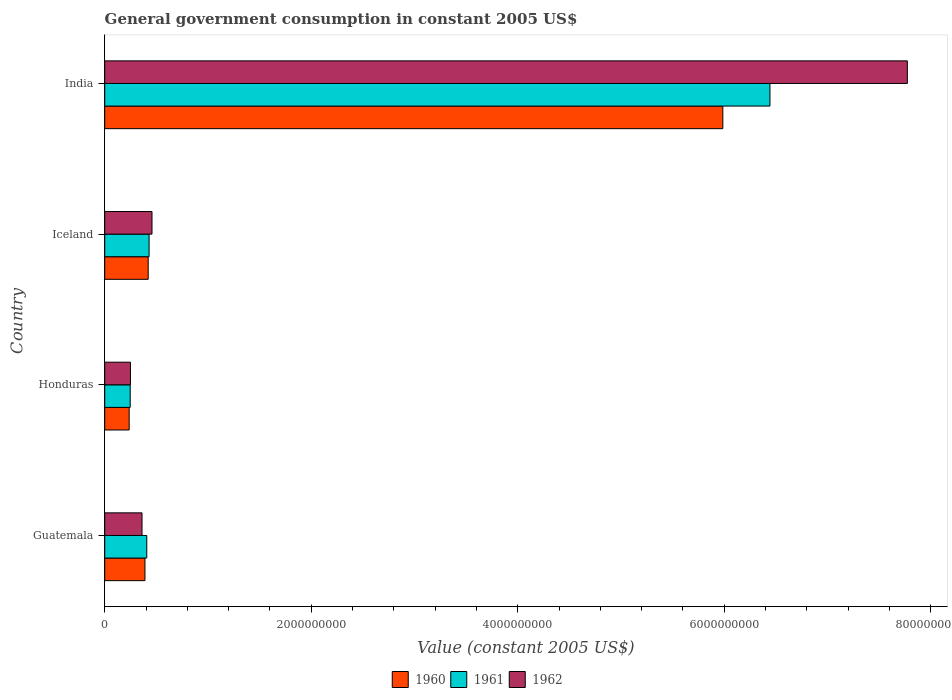What is the government conusmption in 1962 in Guatemala?
Keep it short and to the point. 3.61e+08. Across all countries, what is the maximum government conusmption in 1962?
Your answer should be very brief. 7.77e+09. Across all countries, what is the minimum government conusmption in 1962?
Give a very brief answer. 2.49e+08. In which country was the government conusmption in 1960 maximum?
Offer a terse response. India. In which country was the government conusmption in 1961 minimum?
Offer a terse response. Honduras. What is the total government conusmption in 1961 in the graph?
Your answer should be compact. 7.53e+09. What is the difference between the government conusmption in 1960 in Honduras and that in Iceland?
Your response must be concise. -1.84e+08. What is the difference between the government conusmption in 1960 in India and the government conusmption in 1962 in Honduras?
Your answer should be compact. 5.74e+09. What is the average government conusmption in 1960 per country?
Offer a terse response. 1.76e+09. What is the difference between the government conusmption in 1961 and government conusmption in 1962 in Iceland?
Keep it short and to the point. -2.80e+07. What is the ratio of the government conusmption in 1960 in Guatemala to that in Iceland?
Your response must be concise. 0.93. Is the government conusmption in 1962 in Honduras less than that in Iceland?
Provide a short and direct response. Yes. What is the difference between the highest and the second highest government conusmption in 1962?
Your answer should be compact. 7.32e+09. What is the difference between the highest and the lowest government conusmption in 1961?
Provide a short and direct response. 6.20e+09. What does the 1st bar from the top in Guatemala represents?
Provide a short and direct response. 1962. How many bars are there?
Your answer should be very brief. 12. What is the difference between two consecutive major ticks on the X-axis?
Offer a terse response. 2.00e+09. Where does the legend appear in the graph?
Provide a short and direct response. Bottom center. How many legend labels are there?
Your answer should be very brief. 3. How are the legend labels stacked?
Provide a short and direct response. Horizontal. What is the title of the graph?
Your answer should be compact. General government consumption in constant 2005 US$. Does "1998" appear as one of the legend labels in the graph?
Your answer should be very brief. No. What is the label or title of the X-axis?
Your response must be concise. Value (constant 2005 US$). What is the Value (constant 2005 US$) of 1960 in Guatemala?
Your answer should be very brief. 3.90e+08. What is the Value (constant 2005 US$) of 1961 in Guatemala?
Your response must be concise. 4.07e+08. What is the Value (constant 2005 US$) of 1962 in Guatemala?
Keep it short and to the point. 3.61e+08. What is the Value (constant 2005 US$) of 1960 in Honduras?
Offer a very short reply. 2.37e+08. What is the Value (constant 2005 US$) in 1961 in Honduras?
Keep it short and to the point. 2.47e+08. What is the Value (constant 2005 US$) of 1962 in Honduras?
Offer a terse response. 2.49e+08. What is the Value (constant 2005 US$) in 1960 in Iceland?
Your answer should be compact. 4.21e+08. What is the Value (constant 2005 US$) in 1961 in Iceland?
Offer a very short reply. 4.30e+08. What is the Value (constant 2005 US$) of 1962 in Iceland?
Your answer should be very brief. 4.58e+08. What is the Value (constant 2005 US$) in 1960 in India?
Offer a very short reply. 5.99e+09. What is the Value (constant 2005 US$) in 1961 in India?
Ensure brevity in your answer.  6.44e+09. What is the Value (constant 2005 US$) in 1962 in India?
Provide a succinct answer. 7.77e+09. Across all countries, what is the maximum Value (constant 2005 US$) of 1960?
Your response must be concise. 5.99e+09. Across all countries, what is the maximum Value (constant 2005 US$) of 1961?
Provide a succinct answer. 6.44e+09. Across all countries, what is the maximum Value (constant 2005 US$) in 1962?
Your answer should be compact. 7.77e+09. Across all countries, what is the minimum Value (constant 2005 US$) in 1960?
Make the answer very short. 2.37e+08. Across all countries, what is the minimum Value (constant 2005 US$) of 1961?
Your answer should be very brief. 2.47e+08. Across all countries, what is the minimum Value (constant 2005 US$) of 1962?
Your answer should be compact. 2.49e+08. What is the total Value (constant 2005 US$) in 1960 in the graph?
Your response must be concise. 7.03e+09. What is the total Value (constant 2005 US$) in 1961 in the graph?
Make the answer very short. 7.53e+09. What is the total Value (constant 2005 US$) of 1962 in the graph?
Offer a very short reply. 8.84e+09. What is the difference between the Value (constant 2005 US$) in 1960 in Guatemala and that in Honduras?
Ensure brevity in your answer.  1.53e+08. What is the difference between the Value (constant 2005 US$) in 1961 in Guatemala and that in Honduras?
Offer a very short reply. 1.60e+08. What is the difference between the Value (constant 2005 US$) of 1962 in Guatemala and that in Honduras?
Keep it short and to the point. 1.12e+08. What is the difference between the Value (constant 2005 US$) of 1960 in Guatemala and that in Iceland?
Provide a short and direct response. -3.13e+07. What is the difference between the Value (constant 2005 US$) of 1961 in Guatemala and that in Iceland?
Provide a short and direct response. -2.26e+07. What is the difference between the Value (constant 2005 US$) of 1962 in Guatemala and that in Iceland?
Make the answer very short. -9.66e+07. What is the difference between the Value (constant 2005 US$) in 1960 in Guatemala and that in India?
Your answer should be compact. -5.60e+09. What is the difference between the Value (constant 2005 US$) in 1961 in Guatemala and that in India?
Offer a terse response. -6.04e+09. What is the difference between the Value (constant 2005 US$) of 1962 in Guatemala and that in India?
Offer a very short reply. -7.41e+09. What is the difference between the Value (constant 2005 US$) of 1960 in Honduras and that in Iceland?
Give a very brief answer. -1.84e+08. What is the difference between the Value (constant 2005 US$) in 1961 in Honduras and that in Iceland?
Ensure brevity in your answer.  -1.83e+08. What is the difference between the Value (constant 2005 US$) of 1962 in Honduras and that in Iceland?
Your answer should be very brief. -2.09e+08. What is the difference between the Value (constant 2005 US$) in 1960 in Honduras and that in India?
Your answer should be compact. -5.75e+09. What is the difference between the Value (constant 2005 US$) in 1961 in Honduras and that in India?
Your response must be concise. -6.20e+09. What is the difference between the Value (constant 2005 US$) of 1962 in Honduras and that in India?
Offer a very short reply. -7.52e+09. What is the difference between the Value (constant 2005 US$) in 1960 in Iceland and that in India?
Offer a very short reply. -5.57e+09. What is the difference between the Value (constant 2005 US$) in 1961 in Iceland and that in India?
Offer a very short reply. -6.01e+09. What is the difference between the Value (constant 2005 US$) of 1962 in Iceland and that in India?
Keep it short and to the point. -7.32e+09. What is the difference between the Value (constant 2005 US$) in 1960 in Guatemala and the Value (constant 2005 US$) in 1961 in Honduras?
Provide a short and direct response. 1.43e+08. What is the difference between the Value (constant 2005 US$) of 1960 in Guatemala and the Value (constant 2005 US$) of 1962 in Honduras?
Your response must be concise. 1.40e+08. What is the difference between the Value (constant 2005 US$) of 1961 in Guatemala and the Value (constant 2005 US$) of 1962 in Honduras?
Provide a succinct answer. 1.58e+08. What is the difference between the Value (constant 2005 US$) of 1960 in Guatemala and the Value (constant 2005 US$) of 1961 in Iceland?
Keep it short and to the point. -4.02e+07. What is the difference between the Value (constant 2005 US$) of 1960 in Guatemala and the Value (constant 2005 US$) of 1962 in Iceland?
Offer a very short reply. -6.82e+07. What is the difference between the Value (constant 2005 US$) of 1961 in Guatemala and the Value (constant 2005 US$) of 1962 in Iceland?
Provide a succinct answer. -5.06e+07. What is the difference between the Value (constant 2005 US$) in 1960 in Guatemala and the Value (constant 2005 US$) in 1961 in India?
Provide a short and direct response. -6.05e+09. What is the difference between the Value (constant 2005 US$) of 1960 in Guatemala and the Value (constant 2005 US$) of 1962 in India?
Your response must be concise. -7.38e+09. What is the difference between the Value (constant 2005 US$) in 1961 in Guatemala and the Value (constant 2005 US$) in 1962 in India?
Ensure brevity in your answer.  -7.37e+09. What is the difference between the Value (constant 2005 US$) of 1960 in Honduras and the Value (constant 2005 US$) of 1961 in Iceland?
Provide a succinct answer. -1.93e+08. What is the difference between the Value (constant 2005 US$) in 1960 in Honduras and the Value (constant 2005 US$) in 1962 in Iceland?
Offer a terse response. -2.21e+08. What is the difference between the Value (constant 2005 US$) in 1961 in Honduras and the Value (constant 2005 US$) in 1962 in Iceland?
Keep it short and to the point. -2.11e+08. What is the difference between the Value (constant 2005 US$) in 1960 in Honduras and the Value (constant 2005 US$) in 1961 in India?
Make the answer very short. -6.21e+09. What is the difference between the Value (constant 2005 US$) in 1960 in Honduras and the Value (constant 2005 US$) in 1962 in India?
Your response must be concise. -7.54e+09. What is the difference between the Value (constant 2005 US$) in 1961 in Honduras and the Value (constant 2005 US$) in 1962 in India?
Keep it short and to the point. -7.53e+09. What is the difference between the Value (constant 2005 US$) of 1960 in Iceland and the Value (constant 2005 US$) of 1961 in India?
Keep it short and to the point. -6.02e+09. What is the difference between the Value (constant 2005 US$) of 1960 in Iceland and the Value (constant 2005 US$) of 1962 in India?
Offer a terse response. -7.35e+09. What is the difference between the Value (constant 2005 US$) in 1961 in Iceland and the Value (constant 2005 US$) in 1962 in India?
Provide a succinct answer. -7.34e+09. What is the average Value (constant 2005 US$) in 1960 per country?
Your answer should be compact. 1.76e+09. What is the average Value (constant 2005 US$) in 1961 per country?
Your answer should be very brief. 1.88e+09. What is the average Value (constant 2005 US$) of 1962 per country?
Your answer should be compact. 2.21e+09. What is the difference between the Value (constant 2005 US$) in 1960 and Value (constant 2005 US$) in 1961 in Guatemala?
Make the answer very short. -1.76e+07. What is the difference between the Value (constant 2005 US$) in 1960 and Value (constant 2005 US$) in 1962 in Guatemala?
Your answer should be compact. 2.84e+07. What is the difference between the Value (constant 2005 US$) in 1961 and Value (constant 2005 US$) in 1962 in Guatemala?
Provide a short and direct response. 4.60e+07. What is the difference between the Value (constant 2005 US$) in 1960 and Value (constant 2005 US$) in 1961 in Honduras?
Your answer should be compact. -9.99e+06. What is the difference between the Value (constant 2005 US$) of 1960 and Value (constant 2005 US$) of 1962 in Honduras?
Offer a very short reply. -1.24e+07. What is the difference between the Value (constant 2005 US$) of 1961 and Value (constant 2005 US$) of 1962 in Honduras?
Your answer should be compact. -2.42e+06. What is the difference between the Value (constant 2005 US$) in 1960 and Value (constant 2005 US$) in 1961 in Iceland?
Offer a very short reply. -8.87e+06. What is the difference between the Value (constant 2005 US$) in 1960 and Value (constant 2005 US$) in 1962 in Iceland?
Offer a very short reply. -3.69e+07. What is the difference between the Value (constant 2005 US$) in 1961 and Value (constant 2005 US$) in 1962 in Iceland?
Your response must be concise. -2.80e+07. What is the difference between the Value (constant 2005 US$) of 1960 and Value (constant 2005 US$) of 1961 in India?
Provide a short and direct response. -4.56e+08. What is the difference between the Value (constant 2005 US$) of 1960 and Value (constant 2005 US$) of 1962 in India?
Your answer should be very brief. -1.79e+09. What is the difference between the Value (constant 2005 US$) in 1961 and Value (constant 2005 US$) in 1962 in India?
Ensure brevity in your answer.  -1.33e+09. What is the ratio of the Value (constant 2005 US$) of 1960 in Guatemala to that in Honduras?
Provide a succinct answer. 1.65. What is the ratio of the Value (constant 2005 US$) of 1961 in Guatemala to that in Honduras?
Provide a succinct answer. 1.65. What is the ratio of the Value (constant 2005 US$) in 1962 in Guatemala to that in Honduras?
Keep it short and to the point. 1.45. What is the ratio of the Value (constant 2005 US$) in 1960 in Guatemala to that in Iceland?
Ensure brevity in your answer.  0.93. What is the ratio of the Value (constant 2005 US$) of 1961 in Guatemala to that in Iceland?
Ensure brevity in your answer.  0.95. What is the ratio of the Value (constant 2005 US$) in 1962 in Guatemala to that in Iceland?
Ensure brevity in your answer.  0.79. What is the ratio of the Value (constant 2005 US$) of 1960 in Guatemala to that in India?
Ensure brevity in your answer.  0.07. What is the ratio of the Value (constant 2005 US$) in 1961 in Guatemala to that in India?
Offer a terse response. 0.06. What is the ratio of the Value (constant 2005 US$) of 1962 in Guatemala to that in India?
Give a very brief answer. 0.05. What is the ratio of the Value (constant 2005 US$) in 1960 in Honduras to that in Iceland?
Keep it short and to the point. 0.56. What is the ratio of the Value (constant 2005 US$) of 1961 in Honduras to that in Iceland?
Your answer should be very brief. 0.57. What is the ratio of the Value (constant 2005 US$) of 1962 in Honduras to that in Iceland?
Give a very brief answer. 0.54. What is the ratio of the Value (constant 2005 US$) in 1960 in Honduras to that in India?
Your answer should be compact. 0.04. What is the ratio of the Value (constant 2005 US$) in 1961 in Honduras to that in India?
Keep it short and to the point. 0.04. What is the ratio of the Value (constant 2005 US$) in 1962 in Honduras to that in India?
Your answer should be compact. 0.03. What is the ratio of the Value (constant 2005 US$) of 1960 in Iceland to that in India?
Provide a succinct answer. 0.07. What is the ratio of the Value (constant 2005 US$) of 1961 in Iceland to that in India?
Offer a very short reply. 0.07. What is the ratio of the Value (constant 2005 US$) of 1962 in Iceland to that in India?
Your answer should be compact. 0.06. What is the difference between the highest and the second highest Value (constant 2005 US$) of 1960?
Your response must be concise. 5.57e+09. What is the difference between the highest and the second highest Value (constant 2005 US$) of 1961?
Ensure brevity in your answer.  6.01e+09. What is the difference between the highest and the second highest Value (constant 2005 US$) in 1962?
Make the answer very short. 7.32e+09. What is the difference between the highest and the lowest Value (constant 2005 US$) of 1960?
Offer a terse response. 5.75e+09. What is the difference between the highest and the lowest Value (constant 2005 US$) of 1961?
Ensure brevity in your answer.  6.20e+09. What is the difference between the highest and the lowest Value (constant 2005 US$) in 1962?
Make the answer very short. 7.52e+09. 